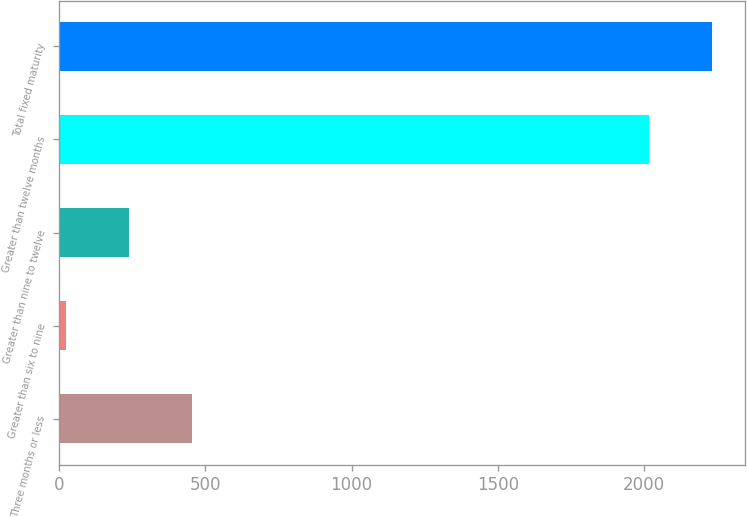<chart> <loc_0><loc_0><loc_500><loc_500><bar_chart><fcel>Three months or less<fcel>Greater than six to nine<fcel>Greater than nine to twelve<fcel>Greater than twelve months<fcel>Total fixed maturity<nl><fcel>453.72<fcel>22.6<fcel>238.16<fcel>2016.8<fcel>2232.36<nl></chart> 